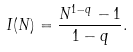<formula> <loc_0><loc_0><loc_500><loc_500>I ( N ) = \frac { N ^ { 1 - q } - 1 } { 1 - q } .</formula> 